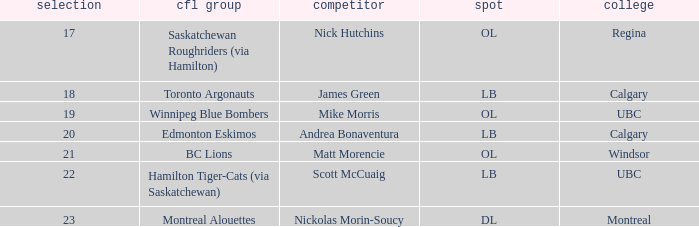What position is the player who went to Regina?  OL. 